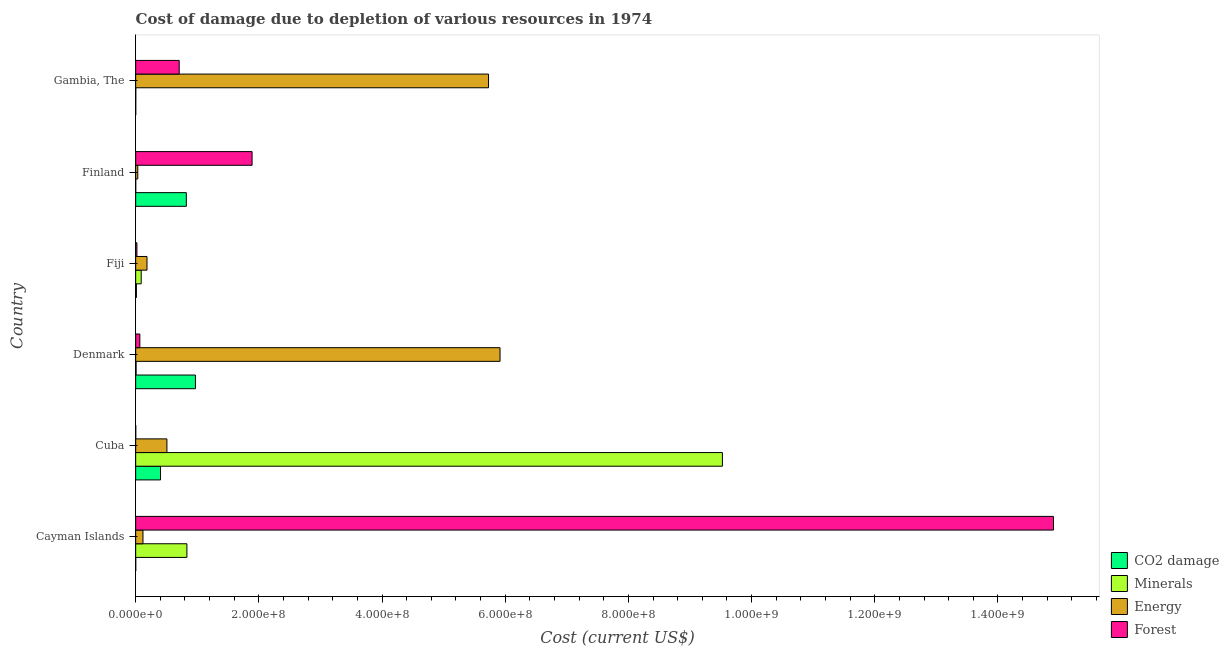How many groups of bars are there?
Your answer should be compact. 6. Are the number of bars per tick equal to the number of legend labels?
Your response must be concise. Yes. Are the number of bars on each tick of the Y-axis equal?
Your answer should be compact. Yes. What is the label of the 2nd group of bars from the top?
Your response must be concise. Finland. What is the cost of damage due to depletion of coal in Denmark?
Your response must be concise. 9.70e+07. Across all countries, what is the maximum cost of damage due to depletion of forests?
Offer a very short reply. 1.49e+09. Across all countries, what is the minimum cost of damage due to depletion of coal?
Give a very brief answer. 9.69e+04. In which country was the cost of damage due to depletion of forests maximum?
Your answer should be compact. Cayman Islands. In which country was the cost of damage due to depletion of forests minimum?
Keep it short and to the point. Cuba. What is the total cost of damage due to depletion of minerals in the graph?
Your response must be concise. 1.05e+09. What is the difference between the cost of damage due to depletion of coal in Denmark and that in Gambia, The?
Offer a terse response. 9.69e+07. What is the difference between the cost of damage due to depletion of minerals in Finland and the cost of damage due to depletion of energy in Gambia, The?
Provide a short and direct response. -5.73e+08. What is the average cost of damage due to depletion of forests per country?
Your answer should be very brief. 2.93e+08. What is the difference between the cost of damage due to depletion of minerals and cost of damage due to depletion of forests in Cayman Islands?
Ensure brevity in your answer.  -1.41e+09. What is the ratio of the cost of damage due to depletion of energy in Fiji to that in Gambia, The?
Offer a very short reply. 0.03. What is the difference between the highest and the second highest cost of damage due to depletion of energy?
Ensure brevity in your answer.  1.87e+07. What is the difference between the highest and the lowest cost of damage due to depletion of forests?
Give a very brief answer. 1.49e+09. In how many countries, is the cost of damage due to depletion of minerals greater than the average cost of damage due to depletion of minerals taken over all countries?
Your response must be concise. 1. What does the 3rd bar from the top in Finland represents?
Your answer should be very brief. Minerals. What does the 4th bar from the bottom in Cuba represents?
Provide a short and direct response. Forest. How many countries are there in the graph?
Provide a succinct answer. 6. Are the values on the major ticks of X-axis written in scientific E-notation?
Your response must be concise. Yes. Does the graph contain any zero values?
Ensure brevity in your answer.  No. How many legend labels are there?
Provide a succinct answer. 4. What is the title of the graph?
Provide a short and direct response. Cost of damage due to depletion of various resources in 1974 . What is the label or title of the X-axis?
Ensure brevity in your answer.  Cost (current US$). What is the Cost (current US$) in CO2 damage in Cayman Islands?
Ensure brevity in your answer.  9.69e+04. What is the Cost (current US$) in Minerals in Cayman Islands?
Offer a terse response. 8.32e+07. What is the Cost (current US$) in Energy in Cayman Islands?
Your response must be concise. 1.19e+07. What is the Cost (current US$) of Forest in Cayman Islands?
Provide a succinct answer. 1.49e+09. What is the Cost (current US$) of CO2 damage in Cuba?
Provide a succinct answer. 4.04e+07. What is the Cost (current US$) of Minerals in Cuba?
Your answer should be very brief. 9.53e+08. What is the Cost (current US$) in Energy in Cuba?
Provide a short and direct response. 5.07e+07. What is the Cost (current US$) in Forest in Cuba?
Your response must be concise. 1.11e+05. What is the Cost (current US$) of CO2 damage in Denmark?
Make the answer very short. 9.70e+07. What is the Cost (current US$) in Minerals in Denmark?
Offer a very short reply. 6.78e+05. What is the Cost (current US$) in Energy in Denmark?
Your answer should be very brief. 5.92e+08. What is the Cost (current US$) in Forest in Denmark?
Provide a succinct answer. 6.79e+06. What is the Cost (current US$) of CO2 damage in Fiji?
Your response must be concise. 1.18e+06. What is the Cost (current US$) in Minerals in Fiji?
Your response must be concise. 8.97e+06. What is the Cost (current US$) of Energy in Fiji?
Provide a short and direct response. 1.84e+07. What is the Cost (current US$) in Forest in Fiji?
Provide a succinct answer. 2.04e+06. What is the Cost (current US$) of CO2 damage in Finland?
Offer a very short reply. 8.23e+07. What is the Cost (current US$) of Minerals in Finland?
Offer a terse response. 7.27e+04. What is the Cost (current US$) in Energy in Finland?
Your answer should be compact. 3.43e+06. What is the Cost (current US$) of Forest in Finland?
Ensure brevity in your answer.  1.89e+08. What is the Cost (current US$) in CO2 damage in Gambia, The?
Your answer should be very brief. 1.10e+05. What is the Cost (current US$) in Minerals in Gambia, The?
Ensure brevity in your answer.  1.43e+05. What is the Cost (current US$) in Energy in Gambia, The?
Keep it short and to the point. 5.73e+08. What is the Cost (current US$) in Forest in Gambia, The?
Provide a short and direct response. 7.07e+07. Across all countries, what is the maximum Cost (current US$) in CO2 damage?
Provide a short and direct response. 9.70e+07. Across all countries, what is the maximum Cost (current US$) in Minerals?
Provide a short and direct response. 9.53e+08. Across all countries, what is the maximum Cost (current US$) in Energy?
Make the answer very short. 5.92e+08. Across all countries, what is the maximum Cost (current US$) of Forest?
Your response must be concise. 1.49e+09. Across all countries, what is the minimum Cost (current US$) in CO2 damage?
Keep it short and to the point. 9.69e+04. Across all countries, what is the minimum Cost (current US$) in Minerals?
Provide a short and direct response. 7.27e+04. Across all countries, what is the minimum Cost (current US$) in Energy?
Ensure brevity in your answer.  3.43e+06. Across all countries, what is the minimum Cost (current US$) in Forest?
Your response must be concise. 1.11e+05. What is the total Cost (current US$) of CO2 damage in the graph?
Provide a succinct answer. 2.21e+08. What is the total Cost (current US$) of Minerals in the graph?
Provide a succinct answer. 1.05e+09. What is the total Cost (current US$) in Energy in the graph?
Provide a succinct answer. 1.25e+09. What is the total Cost (current US$) of Forest in the graph?
Provide a succinct answer. 1.76e+09. What is the difference between the Cost (current US$) of CO2 damage in Cayman Islands and that in Cuba?
Your response must be concise. -4.03e+07. What is the difference between the Cost (current US$) in Minerals in Cayman Islands and that in Cuba?
Offer a very short reply. -8.69e+08. What is the difference between the Cost (current US$) of Energy in Cayman Islands and that in Cuba?
Give a very brief answer. -3.89e+07. What is the difference between the Cost (current US$) in Forest in Cayman Islands and that in Cuba?
Your answer should be very brief. 1.49e+09. What is the difference between the Cost (current US$) of CO2 damage in Cayman Islands and that in Denmark?
Your response must be concise. -9.69e+07. What is the difference between the Cost (current US$) in Minerals in Cayman Islands and that in Denmark?
Make the answer very short. 8.25e+07. What is the difference between the Cost (current US$) in Energy in Cayman Islands and that in Denmark?
Your answer should be compact. -5.80e+08. What is the difference between the Cost (current US$) in Forest in Cayman Islands and that in Denmark?
Provide a short and direct response. 1.48e+09. What is the difference between the Cost (current US$) in CO2 damage in Cayman Islands and that in Fiji?
Your response must be concise. -1.09e+06. What is the difference between the Cost (current US$) in Minerals in Cayman Islands and that in Fiji?
Your answer should be very brief. 7.42e+07. What is the difference between the Cost (current US$) of Energy in Cayman Islands and that in Fiji?
Make the answer very short. -6.55e+06. What is the difference between the Cost (current US$) in Forest in Cayman Islands and that in Fiji?
Make the answer very short. 1.49e+09. What is the difference between the Cost (current US$) in CO2 damage in Cayman Islands and that in Finland?
Your answer should be compact. -8.22e+07. What is the difference between the Cost (current US$) in Minerals in Cayman Islands and that in Finland?
Ensure brevity in your answer.  8.31e+07. What is the difference between the Cost (current US$) of Energy in Cayman Islands and that in Finland?
Provide a short and direct response. 8.42e+06. What is the difference between the Cost (current US$) of Forest in Cayman Islands and that in Finland?
Keep it short and to the point. 1.30e+09. What is the difference between the Cost (current US$) in CO2 damage in Cayman Islands and that in Gambia, The?
Make the answer very short. -1.29e+04. What is the difference between the Cost (current US$) of Minerals in Cayman Islands and that in Gambia, The?
Provide a succinct answer. 8.30e+07. What is the difference between the Cost (current US$) of Energy in Cayman Islands and that in Gambia, The?
Offer a terse response. -5.61e+08. What is the difference between the Cost (current US$) of Forest in Cayman Islands and that in Gambia, The?
Ensure brevity in your answer.  1.42e+09. What is the difference between the Cost (current US$) in CO2 damage in Cuba and that in Denmark?
Ensure brevity in your answer.  -5.67e+07. What is the difference between the Cost (current US$) in Minerals in Cuba and that in Denmark?
Provide a succinct answer. 9.52e+08. What is the difference between the Cost (current US$) of Energy in Cuba and that in Denmark?
Provide a succinct answer. -5.41e+08. What is the difference between the Cost (current US$) of Forest in Cuba and that in Denmark?
Give a very brief answer. -6.67e+06. What is the difference between the Cost (current US$) in CO2 damage in Cuba and that in Fiji?
Ensure brevity in your answer.  3.92e+07. What is the difference between the Cost (current US$) in Minerals in Cuba and that in Fiji?
Offer a very short reply. 9.44e+08. What is the difference between the Cost (current US$) of Energy in Cuba and that in Fiji?
Your response must be concise. 3.23e+07. What is the difference between the Cost (current US$) of Forest in Cuba and that in Fiji?
Make the answer very short. -1.92e+06. What is the difference between the Cost (current US$) in CO2 damage in Cuba and that in Finland?
Ensure brevity in your answer.  -4.19e+07. What is the difference between the Cost (current US$) in Minerals in Cuba and that in Finland?
Your answer should be very brief. 9.53e+08. What is the difference between the Cost (current US$) of Energy in Cuba and that in Finland?
Your answer should be compact. 4.73e+07. What is the difference between the Cost (current US$) in Forest in Cuba and that in Finland?
Your response must be concise. -1.89e+08. What is the difference between the Cost (current US$) in CO2 damage in Cuba and that in Gambia, The?
Offer a terse response. 4.03e+07. What is the difference between the Cost (current US$) in Minerals in Cuba and that in Gambia, The?
Provide a short and direct response. 9.53e+08. What is the difference between the Cost (current US$) of Energy in Cuba and that in Gambia, The?
Keep it short and to the point. -5.22e+08. What is the difference between the Cost (current US$) of Forest in Cuba and that in Gambia, The?
Keep it short and to the point. -7.06e+07. What is the difference between the Cost (current US$) of CO2 damage in Denmark and that in Fiji?
Offer a very short reply. 9.59e+07. What is the difference between the Cost (current US$) in Minerals in Denmark and that in Fiji?
Your response must be concise. -8.29e+06. What is the difference between the Cost (current US$) of Energy in Denmark and that in Fiji?
Offer a terse response. 5.73e+08. What is the difference between the Cost (current US$) of Forest in Denmark and that in Fiji?
Your response must be concise. 4.75e+06. What is the difference between the Cost (current US$) in CO2 damage in Denmark and that in Finland?
Keep it short and to the point. 1.48e+07. What is the difference between the Cost (current US$) of Minerals in Denmark and that in Finland?
Ensure brevity in your answer.  6.05e+05. What is the difference between the Cost (current US$) of Energy in Denmark and that in Finland?
Ensure brevity in your answer.  5.88e+08. What is the difference between the Cost (current US$) of Forest in Denmark and that in Finland?
Keep it short and to the point. -1.82e+08. What is the difference between the Cost (current US$) of CO2 damage in Denmark and that in Gambia, The?
Offer a terse response. 9.69e+07. What is the difference between the Cost (current US$) of Minerals in Denmark and that in Gambia, The?
Make the answer very short. 5.35e+05. What is the difference between the Cost (current US$) of Energy in Denmark and that in Gambia, The?
Make the answer very short. 1.87e+07. What is the difference between the Cost (current US$) in Forest in Denmark and that in Gambia, The?
Offer a very short reply. -6.39e+07. What is the difference between the Cost (current US$) of CO2 damage in Fiji and that in Finland?
Keep it short and to the point. -8.11e+07. What is the difference between the Cost (current US$) in Minerals in Fiji and that in Finland?
Your response must be concise. 8.90e+06. What is the difference between the Cost (current US$) in Energy in Fiji and that in Finland?
Keep it short and to the point. 1.50e+07. What is the difference between the Cost (current US$) of Forest in Fiji and that in Finland?
Ensure brevity in your answer.  -1.87e+08. What is the difference between the Cost (current US$) in CO2 damage in Fiji and that in Gambia, The?
Offer a terse response. 1.07e+06. What is the difference between the Cost (current US$) of Minerals in Fiji and that in Gambia, The?
Your response must be concise. 8.83e+06. What is the difference between the Cost (current US$) in Energy in Fiji and that in Gambia, The?
Your response must be concise. -5.55e+08. What is the difference between the Cost (current US$) of Forest in Fiji and that in Gambia, The?
Give a very brief answer. -6.86e+07. What is the difference between the Cost (current US$) in CO2 damage in Finland and that in Gambia, The?
Your response must be concise. 8.21e+07. What is the difference between the Cost (current US$) of Minerals in Finland and that in Gambia, The?
Give a very brief answer. -7.06e+04. What is the difference between the Cost (current US$) of Energy in Finland and that in Gambia, The?
Your answer should be compact. -5.69e+08. What is the difference between the Cost (current US$) of Forest in Finland and that in Gambia, The?
Your response must be concise. 1.18e+08. What is the difference between the Cost (current US$) of CO2 damage in Cayman Islands and the Cost (current US$) of Minerals in Cuba?
Your response must be concise. -9.53e+08. What is the difference between the Cost (current US$) of CO2 damage in Cayman Islands and the Cost (current US$) of Energy in Cuba?
Offer a very short reply. -5.06e+07. What is the difference between the Cost (current US$) in CO2 damage in Cayman Islands and the Cost (current US$) in Forest in Cuba?
Provide a succinct answer. -1.43e+04. What is the difference between the Cost (current US$) in Minerals in Cayman Islands and the Cost (current US$) in Energy in Cuba?
Your answer should be very brief. 3.24e+07. What is the difference between the Cost (current US$) in Minerals in Cayman Islands and the Cost (current US$) in Forest in Cuba?
Your answer should be compact. 8.31e+07. What is the difference between the Cost (current US$) of Energy in Cayman Islands and the Cost (current US$) of Forest in Cuba?
Provide a short and direct response. 1.17e+07. What is the difference between the Cost (current US$) of CO2 damage in Cayman Islands and the Cost (current US$) of Minerals in Denmark?
Provide a short and direct response. -5.81e+05. What is the difference between the Cost (current US$) in CO2 damage in Cayman Islands and the Cost (current US$) in Energy in Denmark?
Your response must be concise. -5.91e+08. What is the difference between the Cost (current US$) in CO2 damage in Cayman Islands and the Cost (current US$) in Forest in Denmark?
Your answer should be compact. -6.69e+06. What is the difference between the Cost (current US$) of Minerals in Cayman Islands and the Cost (current US$) of Energy in Denmark?
Offer a terse response. -5.08e+08. What is the difference between the Cost (current US$) of Minerals in Cayman Islands and the Cost (current US$) of Forest in Denmark?
Your response must be concise. 7.64e+07. What is the difference between the Cost (current US$) in Energy in Cayman Islands and the Cost (current US$) in Forest in Denmark?
Keep it short and to the point. 5.07e+06. What is the difference between the Cost (current US$) of CO2 damage in Cayman Islands and the Cost (current US$) of Minerals in Fiji?
Offer a very short reply. -8.88e+06. What is the difference between the Cost (current US$) in CO2 damage in Cayman Islands and the Cost (current US$) in Energy in Fiji?
Provide a short and direct response. -1.83e+07. What is the difference between the Cost (current US$) of CO2 damage in Cayman Islands and the Cost (current US$) of Forest in Fiji?
Your answer should be very brief. -1.94e+06. What is the difference between the Cost (current US$) in Minerals in Cayman Islands and the Cost (current US$) in Energy in Fiji?
Your answer should be very brief. 6.48e+07. What is the difference between the Cost (current US$) in Minerals in Cayman Islands and the Cost (current US$) in Forest in Fiji?
Ensure brevity in your answer.  8.11e+07. What is the difference between the Cost (current US$) in Energy in Cayman Islands and the Cost (current US$) in Forest in Fiji?
Your answer should be very brief. 9.82e+06. What is the difference between the Cost (current US$) in CO2 damage in Cayman Islands and the Cost (current US$) in Minerals in Finland?
Provide a succinct answer. 2.42e+04. What is the difference between the Cost (current US$) of CO2 damage in Cayman Islands and the Cost (current US$) of Energy in Finland?
Make the answer very short. -3.33e+06. What is the difference between the Cost (current US$) of CO2 damage in Cayman Islands and the Cost (current US$) of Forest in Finland?
Ensure brevity in your answer.  -1.89e+08. What is the difference between the Cost (current US$) in Minerals in Cayman Islands and the Cost (current US$) in Energy in Finland?
Offer a terse response. 7.97e+07. What is the difference between the Cost (current US$) in Minerals in Cayman Islands and the Cost (current US$) in Forest in Finland?
Provide a succinct answer. -1.06e+08. What is the difference between the Cost (current US$) in Energy in Cayman Islands and the Cost (current US$) in Forest in Finland?
Give a very brief answer. -1.77e+08. What is the difference between the Cost (current US$) of CO2 damage in Cayman Islands and the Cost (current US$) of Minerals in Gambia, The?
Offer a terse response. -4.64e+04. What is the difference between the Cost (current US$) of CO2 damage in Cayman Islands and the Cost (current US$) of Energy in Gambia, The?
Your answer should be very brief. -5.73e+08. What is the difference between the Cost (current US$) in CO2 damage in Cayman Islands and the Cost (current US$) in Forest in Gambia, The?
Your answer should be very brief. -7.06e+07. What is the difference between the Cost (current US$) in Minerals in Cayman Islands and the Cost (current US$) in Energy in Gambia, The?
Provide a succinct answer. -4.90e+08. What is the difference between the Cost (current US$) in Minerals in Cayman Islands and the Cost (current US$) in Forest in Gambia, The?
Offer a terse response. 1.25e+07. What is the difference between the Cost (current US$) of Energy in Cayman Islands and the Cost (current US$) of Forest in Gambia, The?
Ensure brevity in your answer.  -5.88e+07. What is the difference between the Cost (current US$) of CO2 damage in Cuba and the Cost (current US$) of Minerals in Denmark?
Give a very brief answer. 3.97e+07. What is the difference between the Cost (current US$) in CO2 damage in Cuba and the Cost (current US$) in Energy in Denmark?
Keep it short and to the point. -5.51e+08. What is the difference between the Cost (current US$) of CO2 damage in Cuba and the Cost (current US$) of Forest in Denmark?
Provide a succinct answer. 3.36e+07. What is the difference between the Cost (current US$) of Minerals in Cuba and the Cost (current US$) of Energy in Denmark?
Your answer should be very brief. 3.61e+08. What is the difference between the Cost (current US$) in Minerals in Cuba and the Cost (current US$) in Forest in Denmark?
Your response must be concise. 9.46e+08. What is the difference between the Cost (current US$) in Energy in Cuba and the Cost (current US$) in Forest in Denmark?
Offer a very short reply. 4.40e+07. What is the difference between the Cost (current US$) of CO2 damage in Cuba and the Cost (current US$) of Minerals in Fiji?
Your answer should be compact. 3.14e+07. What is the difference between the Cost (current US$) of CO2 damage in Cuba and the Cost (current US$) of Energy in Fiji?
Offer a very short reply. 2.20e+07. What is the difference between the Cost (current US$) in CO2 damage in Cuba and the Cost (current US$) in Forest in Fiji?
Give a very brief answer. 3.83e+07. What is the difference between the Cost (current US$) in Minerals in Cuba and the Cost (current US$) in Energy in Fiji?
Make the answer very short. 9.34e+08. What is the difference between the Cost (current US$) in Minerals in Cuba and the Cost (current US$) in Forest in Fiji?
Keep it short and to the point. 9.51e+08. What is the difference between the Cost (current US$) in Energy in Cuba and the Cost (current US$) in Forest in Fiji?
Offer a very short reply. 4.87e+07. What is the difference between the Cost (current US$) of CO2 damage in Cuba and the Cost (current US$) of Minerals in Finland?
Give a very brief answer. 4.03e+07. What is the difference between the Cost (current US$) of CO2 damage in Cuba and the Cost (current US$) of Energy in Finland?
Ensure brevity in your answer.  3.69e+07. What is the difference between the Cost (current US$) in CO2 damage in Cuba and the Cost (current US$) in Forest in Finland?
Provide a succinct answer. -1.49e+08. What is the difference between the Cost (current US$) of Minerals in Cuba and the Cost (current US$) of Energy in Finland?
Offer a very short reply. 9.49e+08. What is the difference between the Cost (current US$) of Minerals in Cuba and the Cost (current US$) of Forest in Finland?
Keep it short and to the point. 7.64e+08. What is the difference between the Cost (current US$) in Energy in Cuba and the Cost (current US$) in Forest in Finland?
Provide a succinct answer. -1.38e+08. What is the difference between the Cost (current US$) in CO2 damage in Cuba and the Cost (current US$) in Minerals in Gambia, The?
Your answer should be compact. 4.02e+07. What is the difference between the Cost (current US$) of CO2 damage in Cuba and the Cost (current US$) of Energy in Gambia, The?
Make the answer very short. -5.33e+08. What is the difference between the Cost (current US$) of CO2 damage in Cuba and the Cost (current US$) of Forest in Gambia, The?
Offer a very short reply. -3.03e+07. What is the difference between the Cost (current US$) of Minerals in Cuba and the Cost (current US$) of Energy in Gambia, The?
Offer a very short reply. 3.80e+08. What is the difference between the Cost (current US$) of Minerals in Cuba and the Cost (current US$) of Forest in Gambia, The?
Ensure brevity in your answer.  8.82e+08. What is the difference between the Cost (current US$) in Energy in Cuba and the Cost (current US$) in Forest in Gambia, The?
Keep it short and to the point. -1.99e+07. What is the difference between the Cost (current US$) in CO2 damage in Denmark and the Cost (current US$) in Minerals in Fiji?
Make the answer very short. 8.81e+07. What is the difference between the Cost (current US$) of CO2 damage in Denmark and the Cost (current US$) of Energy in Fiji?
Your answer should be compact. 7.86e+07. What is the difference between the Cost (current US$) in CO2 damage in Denmark and the Cost (current US$) in Forest in Fiji?
Ensure brevity in your answer.  9.50e+07. What is the difference between the Cost (current US$) of Minerals in Denmark and the Cost (current US$) of Energy in Fiji?
Your answer should be very brief. -1.77e+07. What is the difference between the Cost (current US$) in Minerals in Denmark and the Cost (current US$) in Forest in Fiji?
Provide a short and direct response. -1.36e+06. What is the difference between the Cost (current US$) in Energy in Denmark and the Cost (current US$) in Forest in Fiji?
Give a very brief answer. 5.90e+08. What is the difference between the Cost (current US$) of CO2 damage in Denmark and the Cost (current US$) of Minerals in Finland?
Provide a short and direct response. 9.70e+07. What is the difference between the Cost (current US$) in CO2 damage in Denmark and the Cost (current US$) in Energy in Finland?
Your answer should be very brief. 9.36e+07. What is the difference between the Cost (current US$) of CO2 damage in Denmark and the Cost (current US$) of Forest in Finland?
Provide a short and direct response. -9.20e+07. What is the difference between the Cost (current US$) of Minerals in Denmark and the Cost (current US$) of Energy in Finland?
Make the answer very short. -2.75e+06. What is the difference between the Cost (current US$) in Minerals in Denmark and the Cost (current US$) in Forest in Finland?
Your answer should be very brief. -1.88e+08. What is the difference between the Cost (current US$) in Energy in Denmark and the Cost (current US$) in Forest in Finland?
Keep it short and to the point. 4.03e+08. What is the difference between the Cost (current US$) in CO2 damage in Denmark and the Cost (current US$) in Minerals in Gambia, The?
Your answer should be compact. 9.69e+07. What is the difference between the Cost (current US$) in CO2 damage in Denmark and the Cost (current US$) in Energy in Gambia, The?
Give a very brief answer. -4.76e+08. What is the difference between the Cost (current US$) of CO2 damage in Denmark and the Cost (current US$) of Forest in Gambia, The?
Your answer should be very brief. 2.64e+07. What is the difference between the Cost (current US$) in Minerals in Denmark and the Cost (current US$) in Energy in Gambia, The?
Provide a short and direct response. -5.72e+08. What is the difference between the Cost (current US$) of Minerals in Denmark and the Cost (current US$) of Forest in Gambia, The?
Your answer should be compact. -7.00e+07. What is the difference between the Cost (current US$) of Energy in Denmark and the Cost (current US$) of Forest in Gambia, The?
Your answer should be compact. 5.21e+08. What is the difference between the Cost (current US$) of CO2 damage in Fiji and the Cost (current US$) of Minerals in Finland?
Offer a terse response. 1.11e+06. What is the difference between the Cost (current US$) in CO2 damage in Fiji and the Cost (current US$) in Energy in Finland?
Give a very brief answer. -2.25e+06. What is the difference between the Cost (current US$) in CO2 damage in Fiji and the Cost (current US$) in Forest in Finland?
Provide a short and direct response. -1.88e+08. What is the difference between the Cost (current US$) of Minerals in Fiji and the Cost (current US$) of Energy in Finland?
Ensure brevity in your answer.  5.54e+06. What is the difference between the Cost (current US$) of Minerals in Fiji and the Cost (current US$) of Forest in Finland?
Offer a very short reply. -1.80e+08. What is the difference between the Cost (current US$) of Energy in Fiji and the Cost (current US$) of Forest in Finland?
Offer a terse response. -1.71e+08. What is the difference between the Cost (current US$) of CO2 damage in Fiji and the Cost (current US$) of Minerals in Gambia, The?
Keep it short and to the point. 1.04e+06. What is the difference between the Cost (current US$) of CO2 damage in Fiji and the Cost (current US$) of Energy in Gambia, The?
Offer a terse response. -5.72e+08. What is the difference between the Cost (current US$) of CO2 damage in Fiji and the Cost (current US$) of Forest in Gambia, The?
Provide a succinct answer. -6.95e+07. What is the difference between the Cost (current US$) of Minerals in Fiji and the Cost (current US$) of Energy in Gambia, The?
Give a very brief answer. -5.64e+08. What is the difference between the Cost (current US$) in Minerals in Fiji and the Cost (current US$) in Forest in Gambia, The?
Your answer should be compact. -6.17e+07. What is the difference between the Cost (current US$) of Energy in Fiji and the Cost (current US$) of Forest in Gambia, The?
Ensure brevity in your answer.  -5.23e+07. What is the difference between the Cost (current US$) in CO2 damage in Finland and the Cost (current US$) in Minerals in Gambia, The?
Provide a succinct answer. 8.21e+07. What is the difference between the Cost (current US$) in CO2 damage in Finland and the Cost (current US$) in Energy in Gambia, The?
Ensure brevity in your answer.  -4.91e+08. What is the difference between the Cost (current US$) of CO2 damage in Finland and the Cost (current US$) of Forest in Gambia, The?
Ensure brevity in your answer.  1.16e+07. What is the difference between the Cost (current US$) of Minerals in Finland and the Cost (current US$) of Energy in Gambia, The?
Provide a succinct answer. -5.73e+08. What is the difference between the Cost (current US$) in Minerals in Finland and the Cost (current US$) in Forest in Gambia, The?
Provide a succinct answer. -7.06e+07. What is the difference between the Cost (current US$) of Energy in Finland and the Cost (current US$) of Forest in Gambia, The?
Offer a terse response. -6.72e+07. What is the average Cost (current US$) in CO2 damage per country?
Provide a succinct answer. 3.68e+07. What is the average Cost (current US$) in Minerals per country?
Offer a terse response. 1.74e+08. What is the average Cost (current US$) in Energy per country?
Ensure brevity in your answer.  2.08e+08. What is the average Cost (current US$) of Forest per country?
Ensure brevity in your answer.  2.93e+08. What is the difference between the Cost (current US$) in CO2 damage and Cost (current US$) in Minerals in Cayman Islands?
Your answer should be compact. -8.31e+07. What is the difference between the Cost (current US$) of CO2 damage and Cost (current US$) of Energy in Cayman Islands?
Ensure brevity in your answer.  -1.18e+07. What is the difference between the Cost (current US$) of CO2 damage and Cost (current US$) of Forest in Cayman Islands?
Give a very brief answer. -1.49e+09. What is the difference between the Cost (current US$) in Minerals and Cost (current US$) in Energy in Cayman Islands?
Ensure brevity in your answer.  7.13e+07. What is the difference between the Cost (current US$) in Minerals and Cost (current US$) in Forest in Cayman Islands?
Your answer should be very brief. -1.41e+09. What is the difference between the Cost (current US$) in Energy and Cost (current US$) in Forest in Cayman Islands?
Ensure brevity in your answer.  -1.48e+09. What is the difference between the Cost (current US$) in CO2 damage and Cost (current US$) in Minerals in Cuba?
Your response must be concise. -9.12e+08. What is the difference between the Cost (current US$) in CO2 damage and Cost (current US$) in Energy in Cuba?
Provide a succinct answer. -1.04e+07. What is the difference between the Cost (current US$) in CO2 damage and Cost (current US$) in Forest in Cuba?
Offer a very short reply. 4.03e+07. What is the difference between the Cost (current US$) in Minerals and Cost (current US$) in Energy in Cuba?
Your answer should be very brief. 9.02e+08. What is the difference between the Cost (current US$) in Minerals and Cost (current US$) in Forest in Cuba?
Keep it short and to the point. 9.53e+08. What is the difference between the Cost (current US$) of Energy and Cost (current US$) of Forest in Cuba?
Your answer should be compact. 5.06e+07. What is the difference between the Cost (current US$) in CO2 damage and Cost (current US$) in Minerals in Denmark?
Keep it short and to the point. 9.64e+07. What is the difference between the Cost (current US$) of CO2 damage and Cost (current US$) of Energy in Denmark?
Offer a very short reply. -4.95e+08. What is the difference between the Cost (current US$) in CO2 damage and Cost (current US$) in Forest in Denmark?
Your answer should be very brief. 9.03e+07. What is the difference between the Cost (current US$) in Minerals and Cost (current US$) in Energy in Denmark?
Your response must be concise. -5.91e+08. What is the difference between the Cost (current US$) in Minerals and Cost (current US$) in Forest in Denmark?
Provide a short and direct response. -6.11e+06. What is the difference between the Cost (current US$) in Energy and Cost (current US$) in Forest in Denmark?
Ensure brevity in your answer.  5.85e+08. What is the difference between the Cost (current US$) of CO2 damage and Cost (current US$) of Minerals in Fiji?
Your response must be concise. -7.79e+06. What is the difference between the Cost (current US$) in CO2 damage and Cost (current US$) in Energy in Fiji?
Give a very brief answer. -1.72e+07. What is the difference between the Cost (current US$) in CO2 damage and Cost (current US$) in Forest in Fiji?
Offer a terse response. -8.54e+05. What is the difference between the Cost (current US$) in Minerals and Cost (current US$) in Energy in Fiji?
Your response must be concise. -9.43e+06. What is the difference between the Cost (current US$) of Minerals and Cost (current US$) of Forest in Fiji?
Ensure brevity in your answer.  6.94e+06. What is the difference between the Cost (current US$) of Energy and Cost (current US$) of Forest in Fiji?
Give a very brief answer. 1.64e+07. What is the difference between the Cost (current US$) of CO2 damage and Cost (current US$) of Minerals in Finland?
Keep it short and to the point. 8.22e+07. What is the difference between the Cost (current US$) of CO2 damage and Cost (current US$) of Energy in Finland?
Provide a succinct answer. 7.88e+07. What is the difference between the Cost (current US$) in CO2 damage and Cost (current US$) in Forest in Finland?
Your answer should be compact. -1.07e+08. What is the difference between the Cost (current US$) of Minerals and Cost (current US$) of Energy in Finland?
Your response must be concise. -3.36e+06. What is the difference between the Cost (current US$) in Minerals and Cost (current US$) in Forest in Finland?
Offer a terse response. -1.89e+08. What is the difference between the Cost (current US$) in Energy and Cost (current US$) in Forest in Finland?
Your response must be concise. -1.86e+08. What is the difference between the Cost (current US$) of CO2 damage and Cost (current US$) of Minerals in Gambia, The?
Your response must be concise. -3.34e+04. What is the difference between the Cost (current US$) in CO2 damage and Cost (current US$) in Energy in Gambia, The?
Your response must be concise. -5.73e+08. What is the difference between the Cost (current US$) in CO2 damage and Cost (current US$) in Forest in Gambia, The?
Keep it short and to the point. -7.06e+07. What is the difference between the Cost (current US$) in Minerals and Cost (current US$) in Energy in Gambia, The?
Give a very brief answer. -5.73e+08. What is the difference between the Cost (current US$) of Minerals and Cost (current US$) of Forest in Gambia, The?
Ensure brevity in your answer.  -7.05e+07. What is the difference between the Cost (current US$) in Energy and Cost (current US$) in Forest in Gambia, The?
Your answer should be very brief. 5.02e+08. What is the ratio of the Cost (current US$) of CO2 damage in Cayman Islands to that in Cuba?
Your answer should be very brief. 0. What is the ratio of the Cost (current US$) of Minerals in Cayman Islands to that in Cuba?
Provide a short and direct response. 0.09. What is the ratio of the Cost (current US$) in Energy in Cayman Islands to that in Cuba?
Your answer should be very brief. 0.23. What is the ratio of the Cost (current US$) of Forest in Cayman Islands to that in Cuba?
Make the answer very short. 1.34e+04. What is the ratio of the Cost (current US$) in Minerals in Cayman Islands to that in Denmark?
Your answer should be compact. 122.64. What is the ratio of the Cost (current US$) in Forest in Cayman Islands to that in Denmark?
Your answer should be compact. 219.62. What is the ratio of the Cost (current US$) of CO2 damage in Cayman Islands to that in Fiji?
Ensure brevity in your answer.  0.08. What is the ratio of the Cost (current US$) of Minerals in Cayman Islands to that in Fiji?
Provide a short and direct response. 9.27. What is the ratio of the Cost (current US$) of Energy in Cayman Islands to that in Fiji?
Offer a very short reply. 0.64. What is the ratio of the Cost (current US$) of Forest in Cayman Islands to that in Fiji?
Ensure brevity in your answer.  731.91. What is the ratio of the Cost (current US$) in CO2 damage in Cayman Islands to that in Finland?
Keep it short and to the point. 0. What is the ratio of the Cost (current US$) of Minerals in Cayman Islands to that in Finland?
Give a very brief answer. 1144.46. What is the ratio of the Cost (current US$) of Energy in Cayman Islands to that in Finland?
Keep it short and to the point. 3.46. What is the ratio of the Cost (current US$) in Forest in Cayman Islands to that in Finland?
Ensure brevity in your answer.  7.88. What is the ratio of the Cost (current US$) in CO2 damage in Cayman Islands to that in Gambia, The?
Ensure brevity in your answer.  0.88. What is the ratio of the Cost (current US$) of Minerals in Cayman Islands to that in Gambia, The?
Keep it short and to the point. 580.49. What is the ratio of the Cost (current US$) of Energy in Cayman Islands to that in Gambia, The?
Your answer should be compact. 0.02. What is the ratio of the Cost (current US$) in Forest in Cayman Islands to that in Gambia, The?
Your response must be concise. 21.09. What is the ratio of the Cost (current US$) in CO2 damage in Cuba to that in Denmark?
Offer a very short reply. 0.42. What is the ratio of the Cost (current US$) in Minerals in Cuba to that in Denmark?
Offer a very short reply. 1404.83. What is the ratio of the Cost (current US$) of Energy in Cuba to that in Denmark?
Offer a terse response. 0.09. What is the ratio of the Cost (current US$) in Forest in Cuba to that in Denmark?
Give a very brief answer. 0.02. What is the ratio of the Cost (current US$) of CO2 damage in Cuba to that in Fiji?
Offer a very short reply. 34.14. What is the ratio of the Cost (current US$) in Minerals in Cuba to that in Fiji?
Keep it short and to the point. 106.18. What is the ratio of the Cost (current US$) of Energy in Cuba to that in Fiji?
Give a very brief answer. 2.76. What is the ratio of the Cost (current US$) of Forest in Cuba to that in Fiji?
Your response must be concise. 0.05. What is the ratio of the Cost (current US$) of CO2 damage in Cuba to that in Finland?
Offer a very short reply. 0.49. What is the ratio of the Cost (current US$) of Minerals in Cuba to that in Finland?
Offer a very short reply. 1.31e+04. What is the ratio of the Cost (current US$) of Energy in Cuba to that in Finland?
Your answer should be very brief. 14.8. What is the ratio of the Cost (current US$) of Forest in Cuba to that in Finland?
Your answer should be very brief. 0. What is the ratio of the Cost (current US$) of CO2 damage in Cuba to that in Gambia, The?
Provide a succinct answer. 367.53. What is the ratio of the Cost (current US$) of Minerals in Cuba to that in Gambia, The?
Offer a very short reply. 6649.48. What is the ratio of the Cost (current US$) of Energy in Cuba to that in Gambia, The?
Offer a very short reply. 0.09. What is the ratio of the Cost (current US$) in Forest in Cuba to that in Gambia, The?
Ensure brevity in your answer.  0. What is the ratio of the Cost (current US$) in CO2 damage in Denmark to that in Fiji?
Keep it short and to the point. 82.08. What is the ratio of the Cost (current US$) of Minerals in Denmark to that in Fiji?
Ensure brevity in your answer.  0.08. What is the ratio of the Cost (current US$) in Energy in Denmark to that in Fiji?
Offer a very short reply. 32.15. What is the ratio of the Cost (current US$) of Forest in Denmark to that in Fiji?
Offer a terse response. 3.33. What is the ratio of the Cost (current US$) of CO2 damage in Denmark to that in Finland?
Ensure brevity in your answer.  1.18. What is the ratio of the Cost (current US$) of Minerals in Denmark to that in Finland?
Your answer should be very brief. 9.33. What is the ratio of the Cost (current US$) in Energy in Denmark to that in Finland?
Give a very brief answer. 172.55. What is the ratio of the Cost (current US$) in Forest in Denmark to that in Finland?
Your answer should be very brief. 0.04. What is the ratio of the Cost (current US$) in CO2 damage in Denmark to that in Gambia, The?
Give a very brief answer. 883.53. What is the ratio of the Cost (current US$) in Minerals in Denmark to that in Gambia, The?
Make the answer very short. 4.73. What is the ratio of the Cost (current US$) in Energy in Denmark to that in Gambia, The?
Keep it short and to the point. 1.03. What is the ratio of the Cost (current US$) of Forest in Denmark to that in Gambia, The?
Provide a succinct answer. 0.1. What is the ratio of the Cost (current US$) of CO2 damage in Fiji to that in Finland?
Offer a very short reply. 0.01. What is the ratio of the Cost (current US$) of Minerals in Fiji to that in Finland?
Offer a terse response. 123.47. What is the ratio of the Cost (current US$) in Energy in Fiji to that in Finland?
Provide a short and direct response. 5.37. What is the ratio of the Cost (current US$) in Forest in Fiji to that in Finland?
Provide a short and direct response. 0.01. What is the ratio of the Cost (current US$) in CO2 damage in Fiji to that in Gambia, The?
Ensure brevity in your answer.  10.76. What is the ratio of the Cost (current US$) of Minerals in Fiji to that in Gambia, The?
Your answer should be compact. 62.62. What is the ratio of the Cost (current US$) in Energy in Fiji to that in Gambia, The?
Make the answer very short. 0.03. What is the ratio of the Cost (current US$) of Forest in Fiji to that in Gambia, The?
Offer a very short reply. 0.03. What is the ratio of the Cost (current US$) of CO2 damage in Finland to that in Gambia, The?
Your response must be concise. 748.82. What is the ratio of the Cost (current US$) in Minerals in Finland to that in Gambia, The?
Your response must be concise. 0.51. What is the ratio of the Cost (current US$) in Energy in Finland to that in Gambia, The?
Your response must be concise. 0.01. What is the ratio of the Cost (current US$) of Forest in Finland to that in Gambia, The?
Ensure brevity in your answer.  2.67. What is the difference between the highest and the second highest Cost (current US$) of CO2 damage?
Your answer should be compact. 1.48e+07. What is the difference between the highest and the second highest Cost (current US$) of Minerals?
Give a very brief answer. 8.69e+08. What is the difference between the highest and the second highest Cost (current US$) in Energy?
Your answer should be compact. 1.87e+07. What is the difference between the highest and the second highest Cost (current US$) in Forest?
Your answer should be compact. 1.30e+09. What is the difference between the highest and the lowest Cost (current US$) in CO2 damage?
Offer a very short reply. 9.69e+07. What is the difference between the highest and the lowest Cost (current US$) of Minerals?
Offer a very short reply. 9.53e+08. What is the difference between the highest and the lowest Cost (current US$) of Energy?
Your answer should be very brief. 5.88e+08. What is the difference between the highest and the lowest Cost (current US$) in Forest?
Your response must be concise. 1.49e+09. 